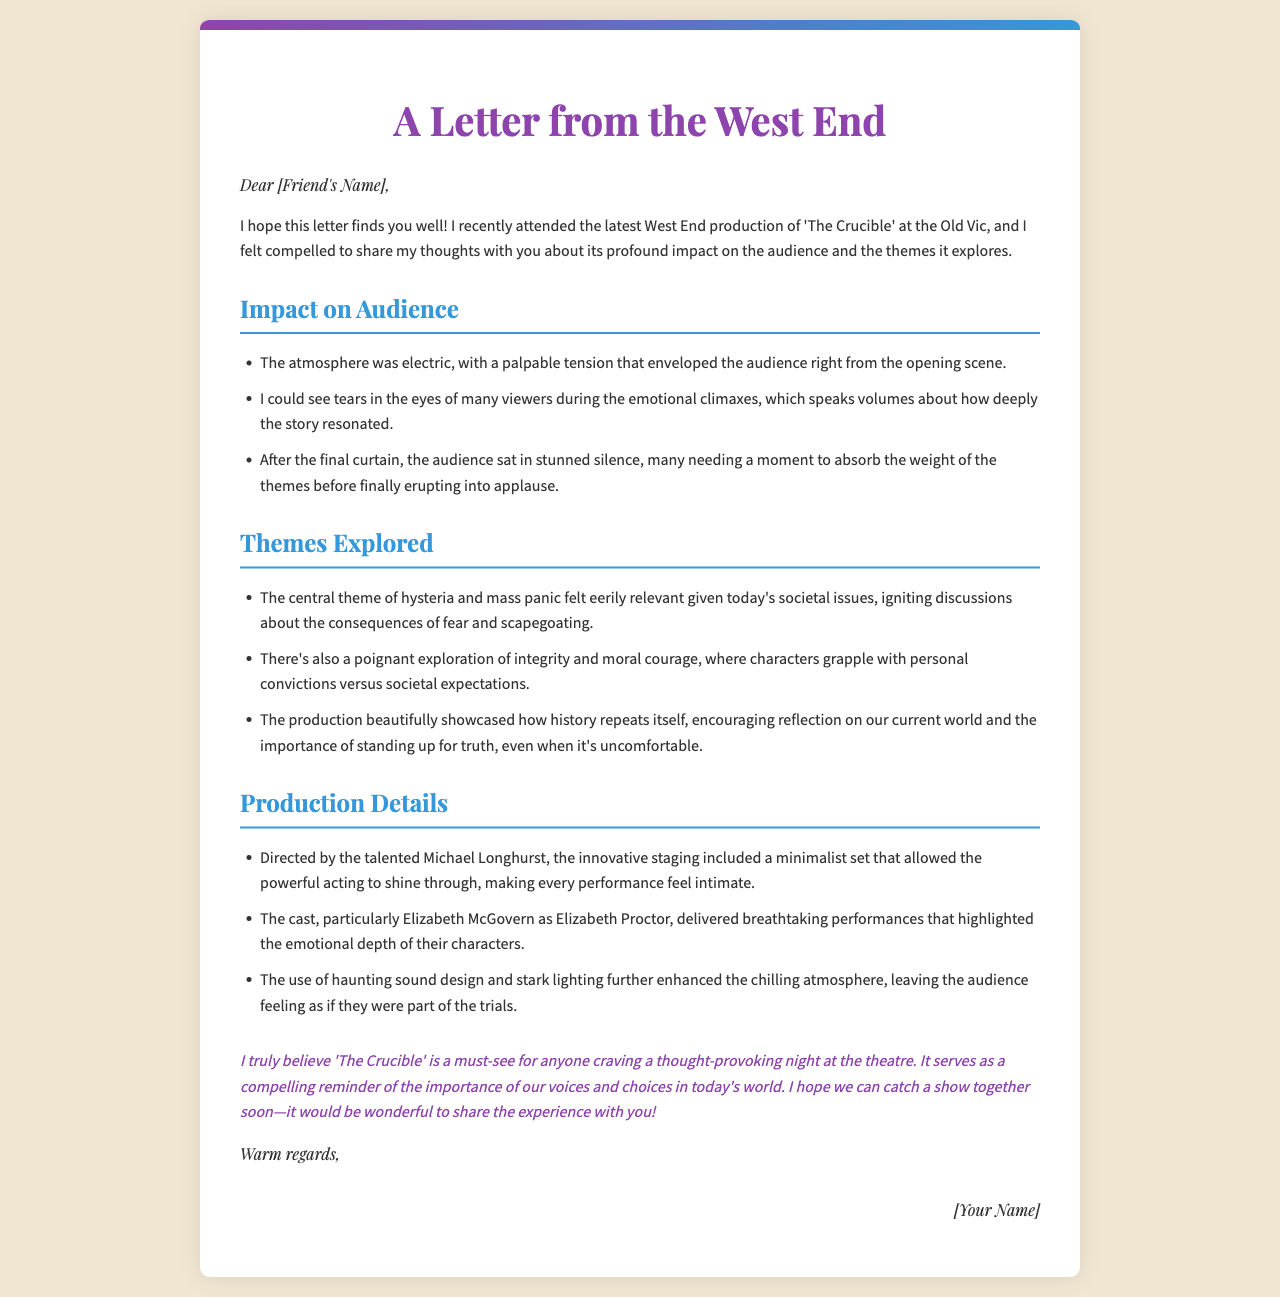What is the title of the production discussed? The title of the production is mentioned in the opening paragraph of the letter.
Answer: The Crucible Who directed the production? The director of the production is explicitly named in the section detailing production details.
Answer: Michael Longhurst What was the audience's reaction after the final curtain? The audience's reaction is described in the impact section of the letter.
Answer: Stunned silence Which character did Elizabeth McGovern portray? The specific role played by Elizabeth McGovern is listed under production details.
Answer: Elizabeth Proctor What theme ignited discussions about consequences in society? The theme that is highlighted in the themes explored section relates to current societal issues.
Answer: Hysteria and mass panic What effect did the staging have on the performance? The impact of the staging is described in terms of its contribution to the overall performance.
Answer: It made every performance feel intimate What was the finishing tone of the letter? The closing remarks of the letter suggest a tone.
Answer: Warm regards How did the letter address the recipient? The greeting section shows how the author addresses the friend.
Answer: Dear [Friend's Name] 